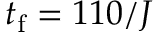Convert formula to latex. <formula><loc_0><loc_0><loc_500><loc_500>t _ { f } = 1 1 0 / J</formula> 